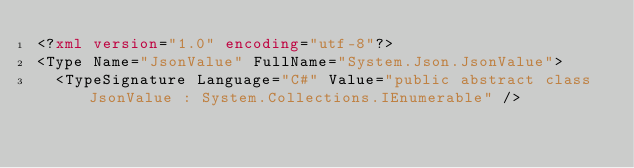Convert code to text. <code><loc_0><loc_0><loc_500><loc_500><_XML_><?xml version="1.0" encoding="utf-8"?>
<Type Name="JsonValue" FullName="System.Json.JsonValue">
  <TypeSignature Language="C#" Value="public abstract class JsonValue : System.Collections.IEnumerable" /></code> 